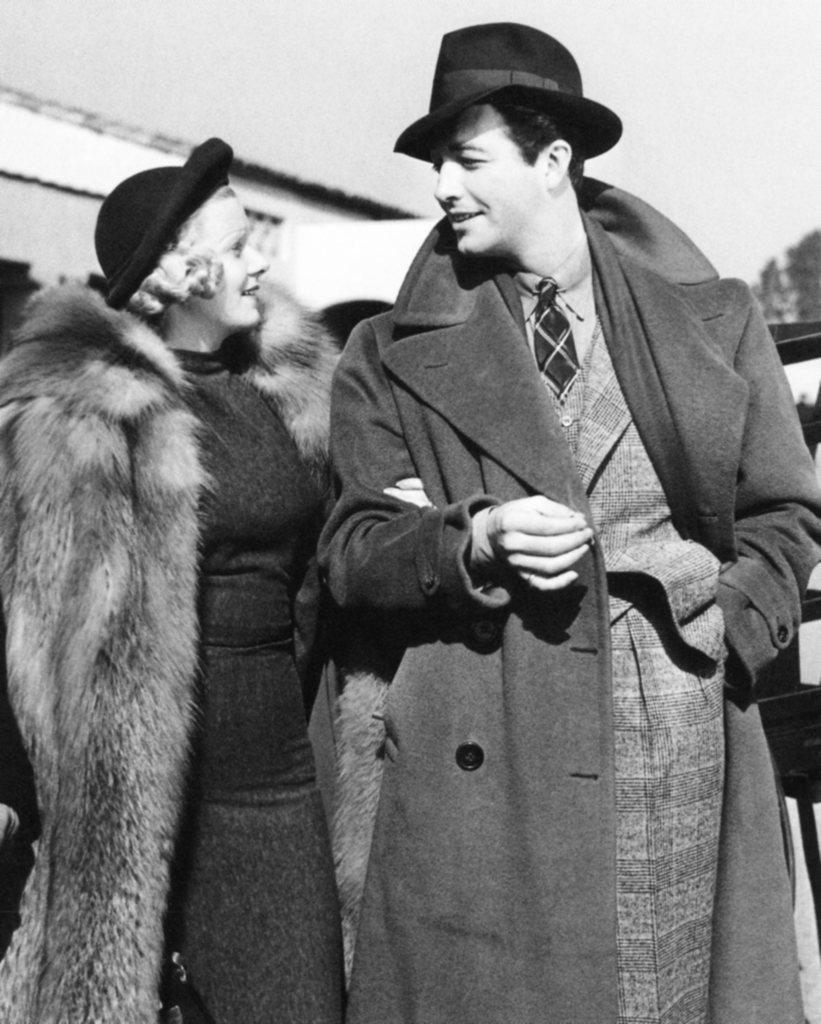What is the man in the image wearing? The man is wearing a coat and a hat. What is the man's facial expression in the image? The man is smiling. Who is standing next to the man in the image? There is a woman standing in the image, and she is on the left side of the man. What is the woman doing in the image? The woman is looking at the man. How would you describe the weather based on the image? The sky is cloudy in the image. Are there any visible cobwebs in the image? There are no cobwebs present in the image. What type of cable can be seen connecting the man and the woman in the image? There is no cable connecting the man and the woman in the image. 